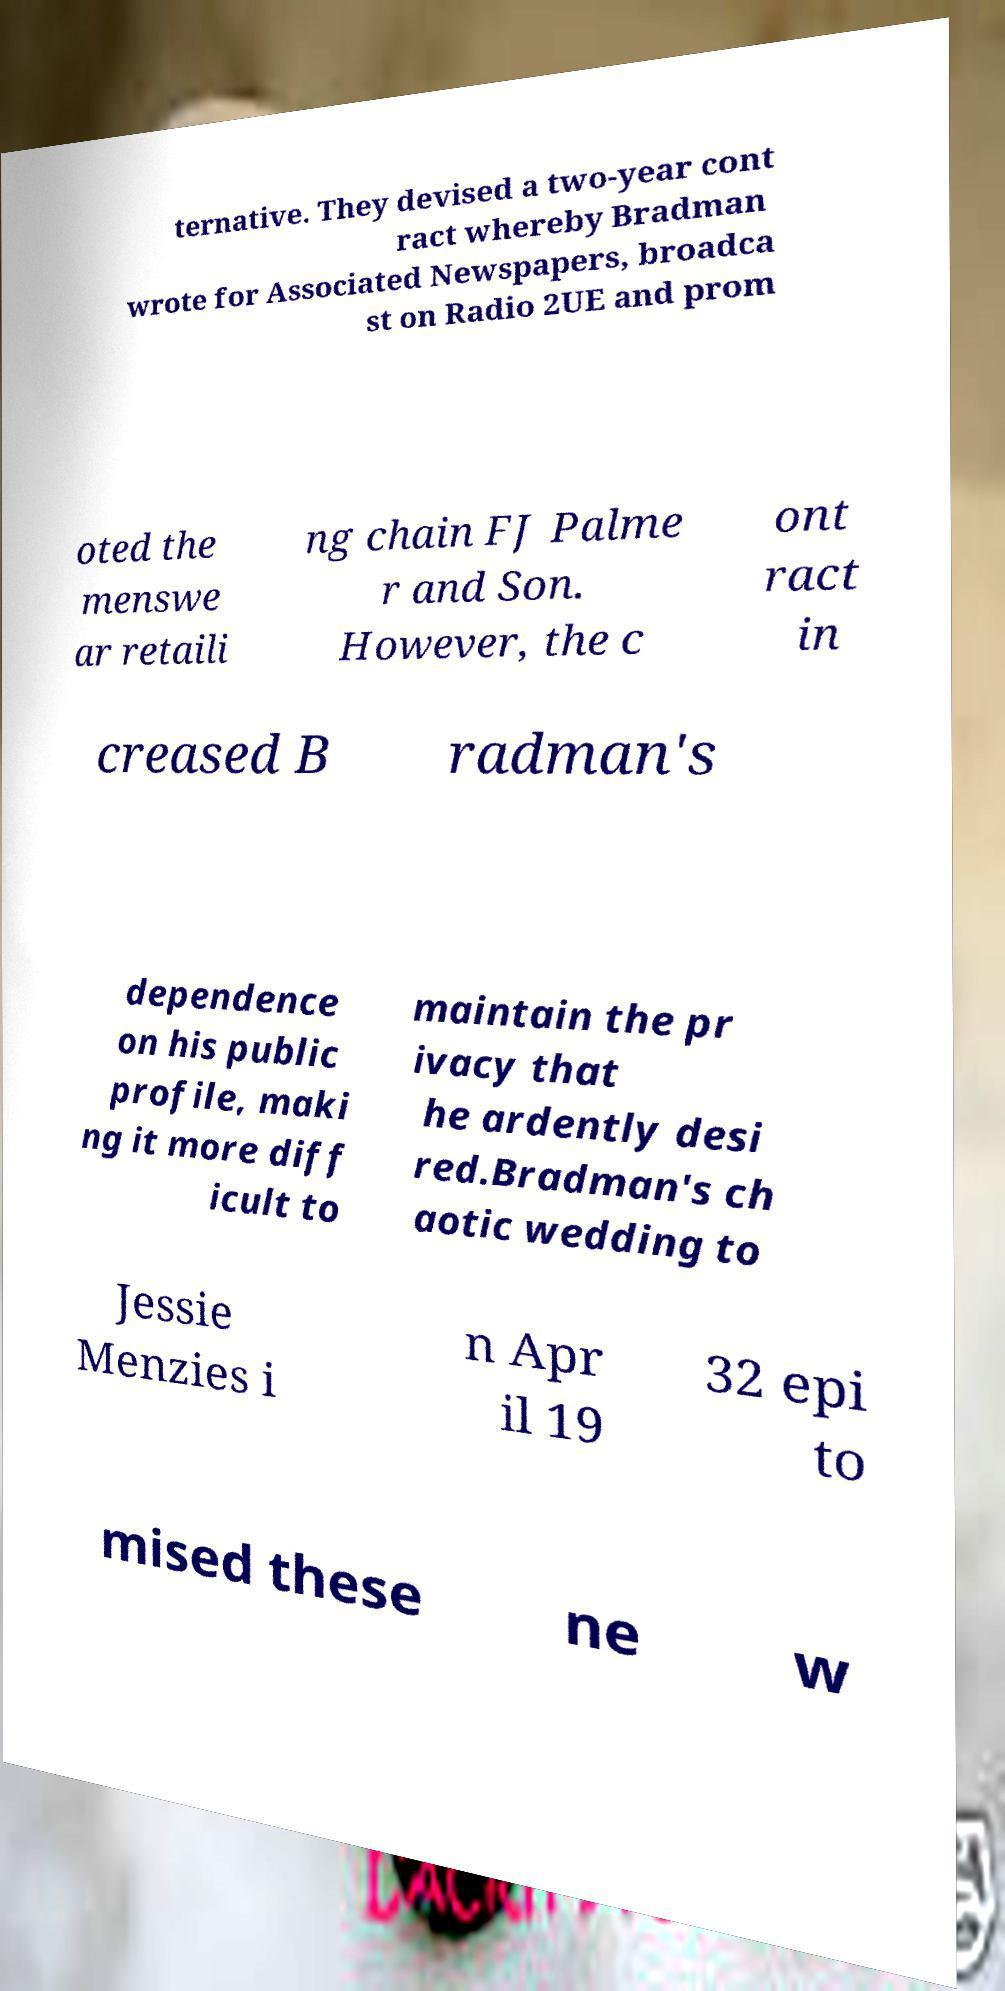For documentation purposes, I need the text within this image transcribed. Could you provide that? ternative. They devised a two-year cont ract whereby Bradman wrote for Associated Newspapers, broadca st on Radio 2UE and prom oted the menswe ar retaili ng chain FJ Palme r and Son. However, the c ont ract in creased B radman's dependence on his public profile, maki ng it more diff icult to maintain the pr ivacy that he ardently desi red.Bradman's ch aotic wedding to Jessie Menzies i n Apr il 19 32 epi to mised these ne w 